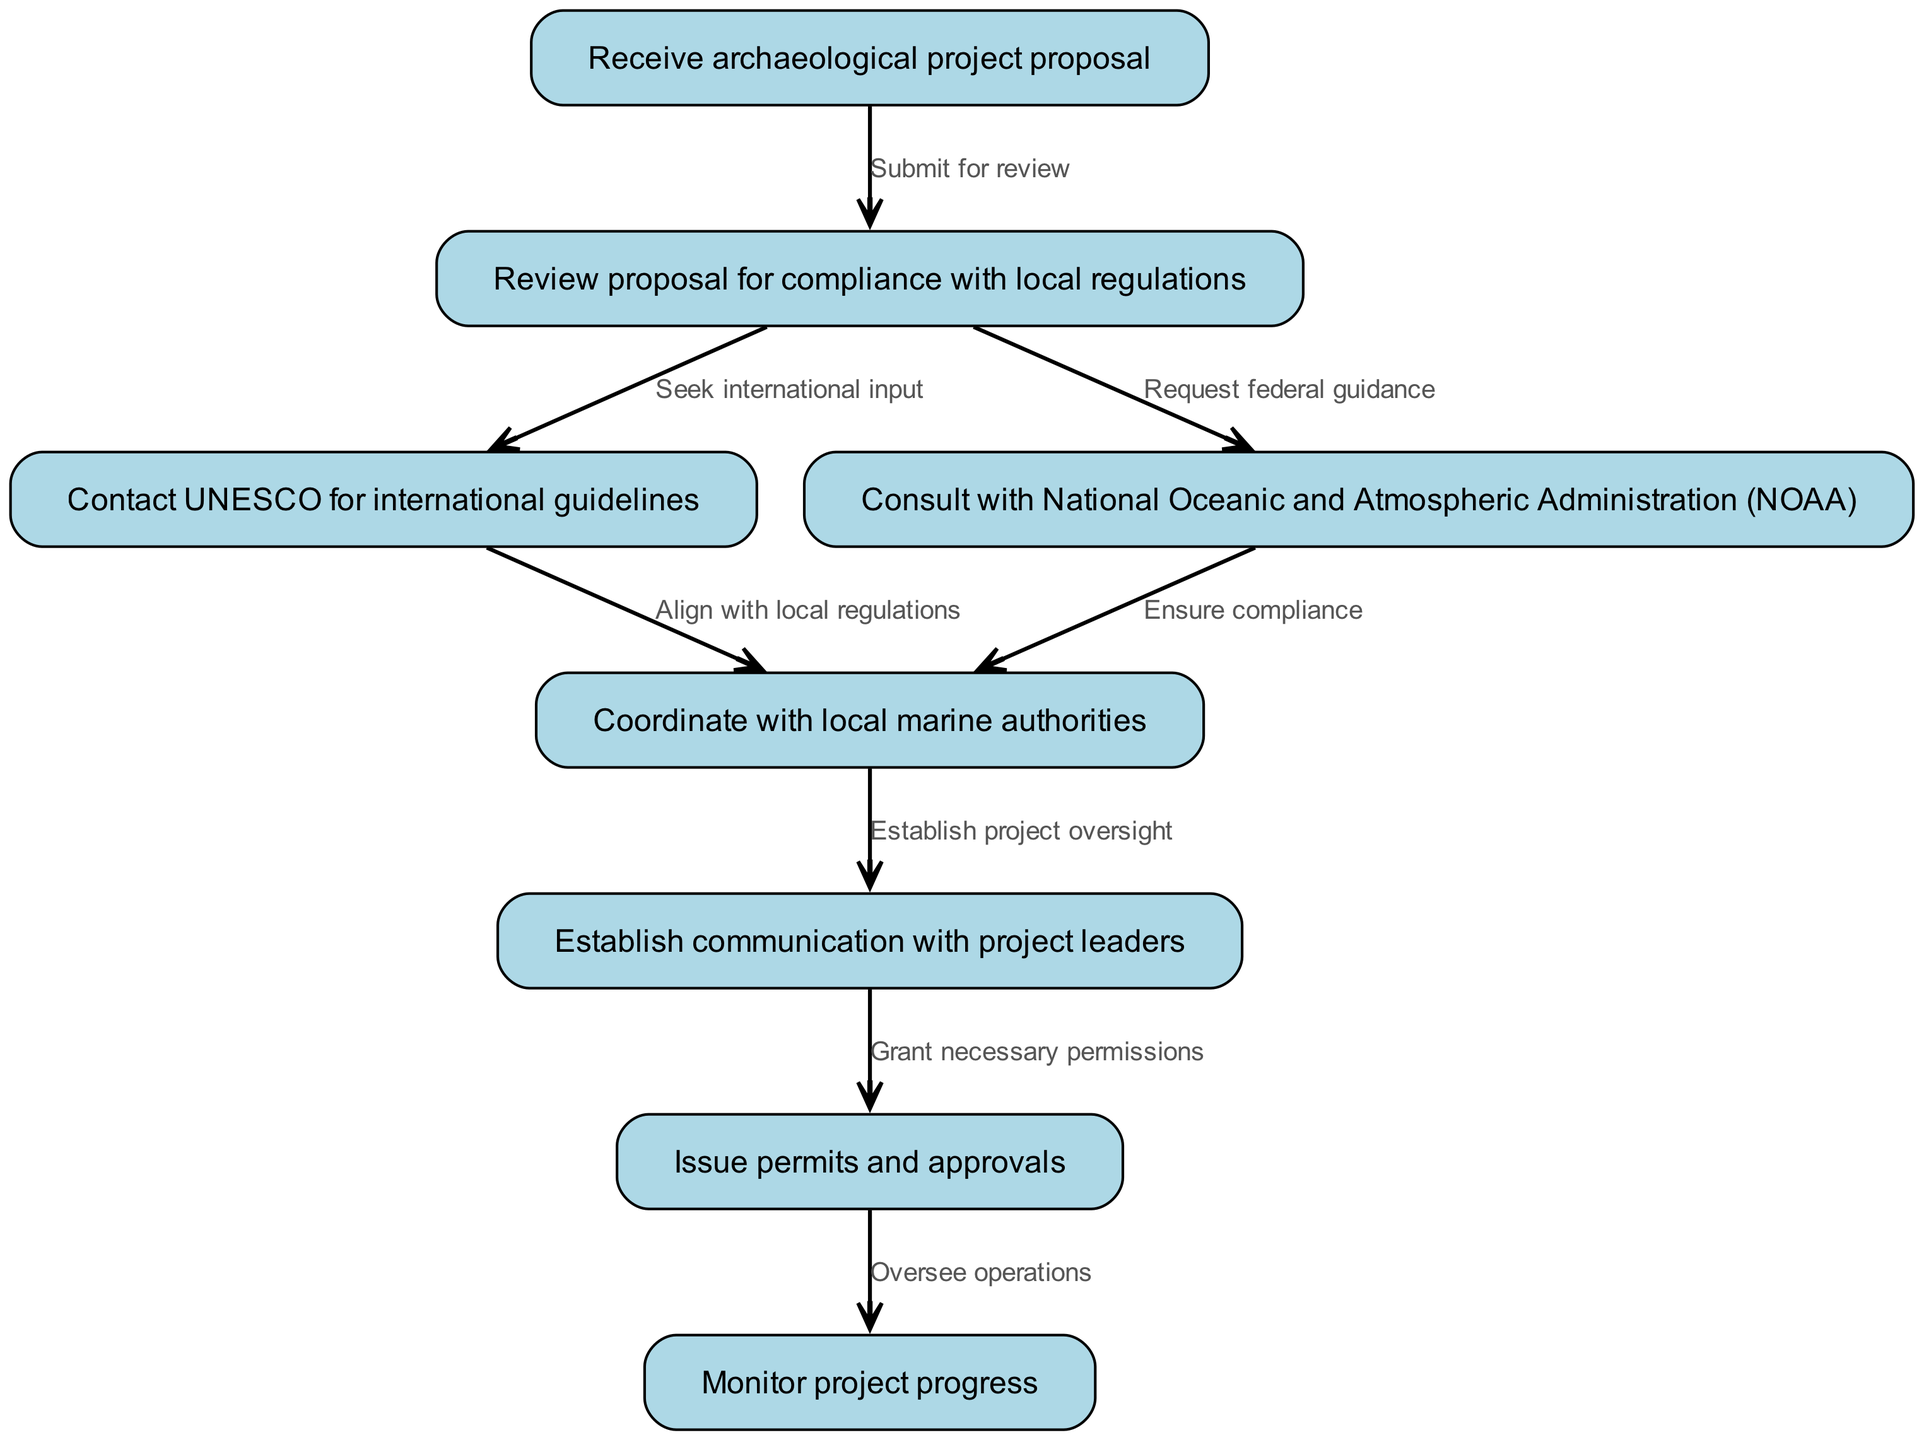What is the first step in the workflow? The workflow starts with the node labeled "Receive archaeological project proposal," which indicates that this is the initial action that triggers the entire process.
Answer: Receive archaeological project proposal How many nodes are present in the diagram? By counting the unique entries in the 'nodes' section of the diagram, we find that there are eight distinct nodes representing the steps in the workflow.
Answer: 8 What is the last step in the workflow? The final action in the diagram is represented by the node "Monitor project progress," which signifies the endpoint of the workflow after permits and approvals are issued.
Answer: Monitor project progress Which node follows the "Review proposal for compliance with local regulations"? The node that follows "Review proposal for compliance with local regulations" is "Contact UNESCO for international guidelines," indicating the next step after the review is completed.
Answer: Contact UNESCO for international guidelines What action is taken after "Establish communication with project leaders"? After establishing communication with project leaders, the next action is "Issue permits and approvals," which indicates a progression toward granting necessary permissions for the project.
Answer: Issue permits and approvals What two organizations are contacted for guidance after reviewing proposals? The two organizations contacted after reviewing proposals are UNESCO and the National Oceanic and Atmospheric Administration (NOAA), as indicated by the edges connecting from the review node to both organizations.
Answer: UNESCO and NOAA What is the purpose of the node "Consult with National Oceanic and Atmospheric Administration (NOAA)"? The purpose of this node is to ensure that the proposal is in alignment with federal guidelines and regulations related to underwater archaeological activities, helping to navigate compliance issues.
Answer: Ensure compliance How many edges are connecting to the node "Coordinate with local marine authorities"? There is one edge connecting to the node "Coordinate with local marine authorities," indicating that it is a singular action linked to the prior step of establishing project oversight.
Answer: 1 What does the arrow from "Issue permits and approvals" to "Monitor project progress" signify? The arrow indicates a directional flow of the process, showing that after permits and approvals are issued, the next step is to oversee or monitor the progress of the archaeological project.
Answer: Oversee operations 